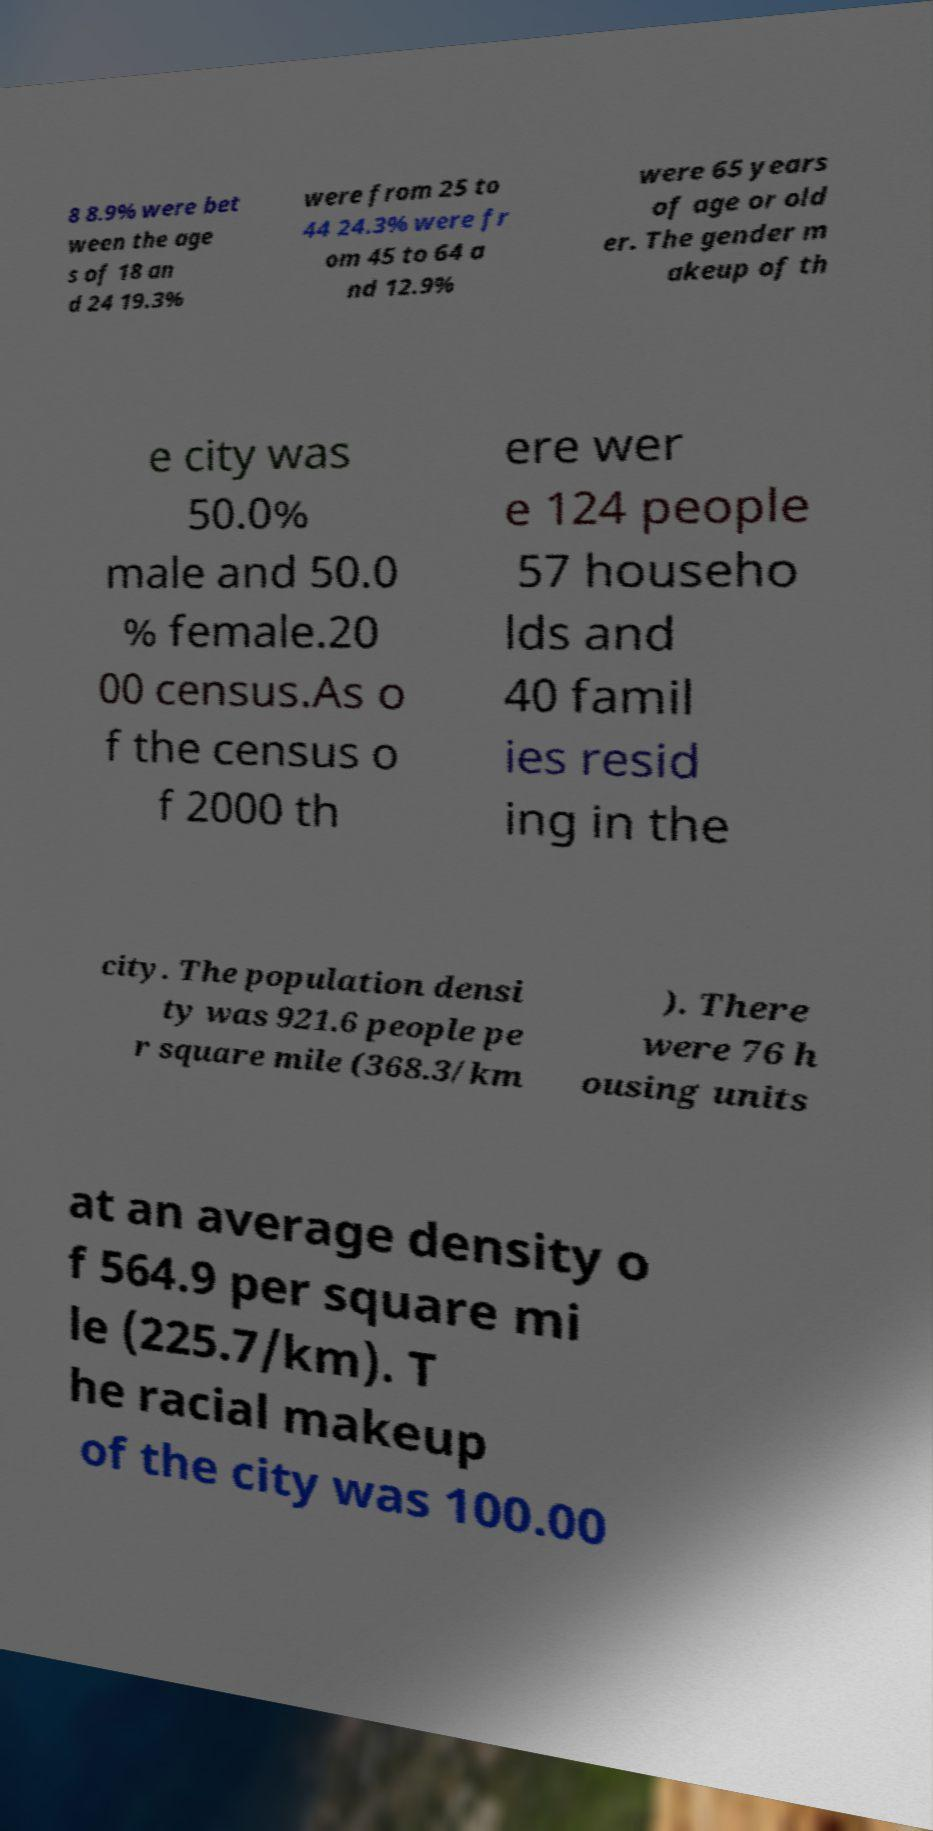Could you extract and type out the text from this image? 8 8.9% were bet ween the age s of 18 an d 24 19.3% were from 25 to 44 24.3% were fr om 45 to 64 a nd 12.9% were 65 years of age or old er. The gender m akeup of th e city was 50.0% male and 50.0 % female.20 00 census.As o f the census o f 2000 th ere wer e 124 people 57 househo lds and 40 famil ies resid ing in the city. The population densi ty was 921.6 people pe r square mile (368.3/km ). There were 76 h ousing units at an average density o f 564.9 per square mi le (225.7/km). T he racial makeup of the city was 100.00 